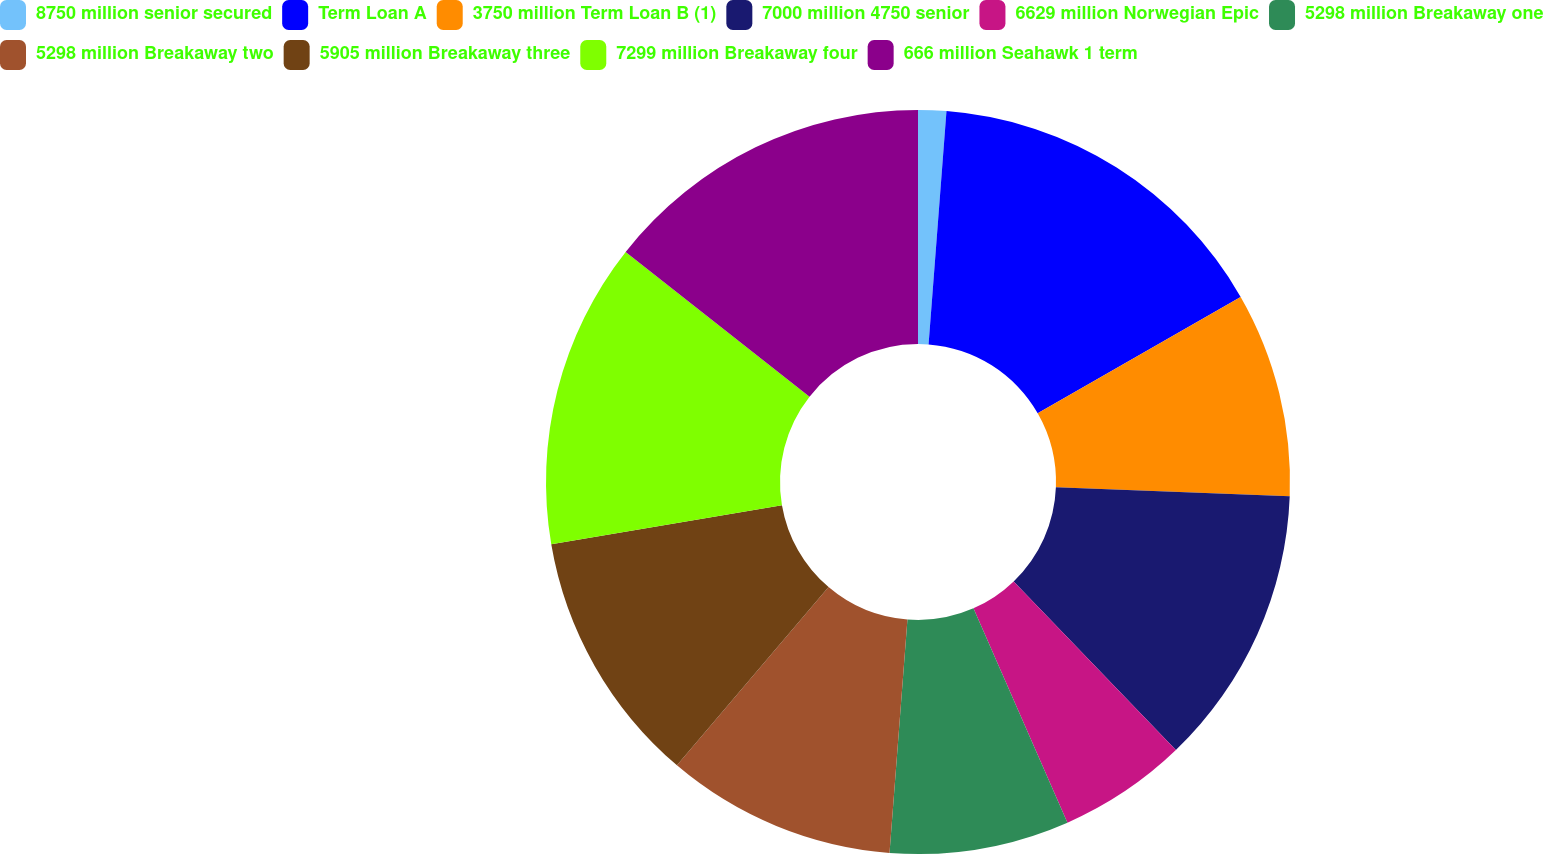Convert chart. <chart><loc_0><loc_0><loc_500><loc_500><pie_chart><fcel>8750 million senior secured<fcel>Term Loan A<fcel>3750 million Term Loan B (1)<fcel>7000 million 4750 senior<fcel>6629 million Norwegian Epic<fcel>5298 million Breakaway one<fcel>5298 million Breakaway two<fcel>5905 million Breakaway three<fcel>7299 million Breakaway four<fcel>666 million Seahawk 1 term<nl><fcel>1.22%<fcel>15.49%<fcel>8.9%<fcel>12.2%<fcel>5.61%<fcel>7.8%<fcel>10.0%<fcel>11.1%<fcel>13.29%<fcel>14.39%<nl></chart> 